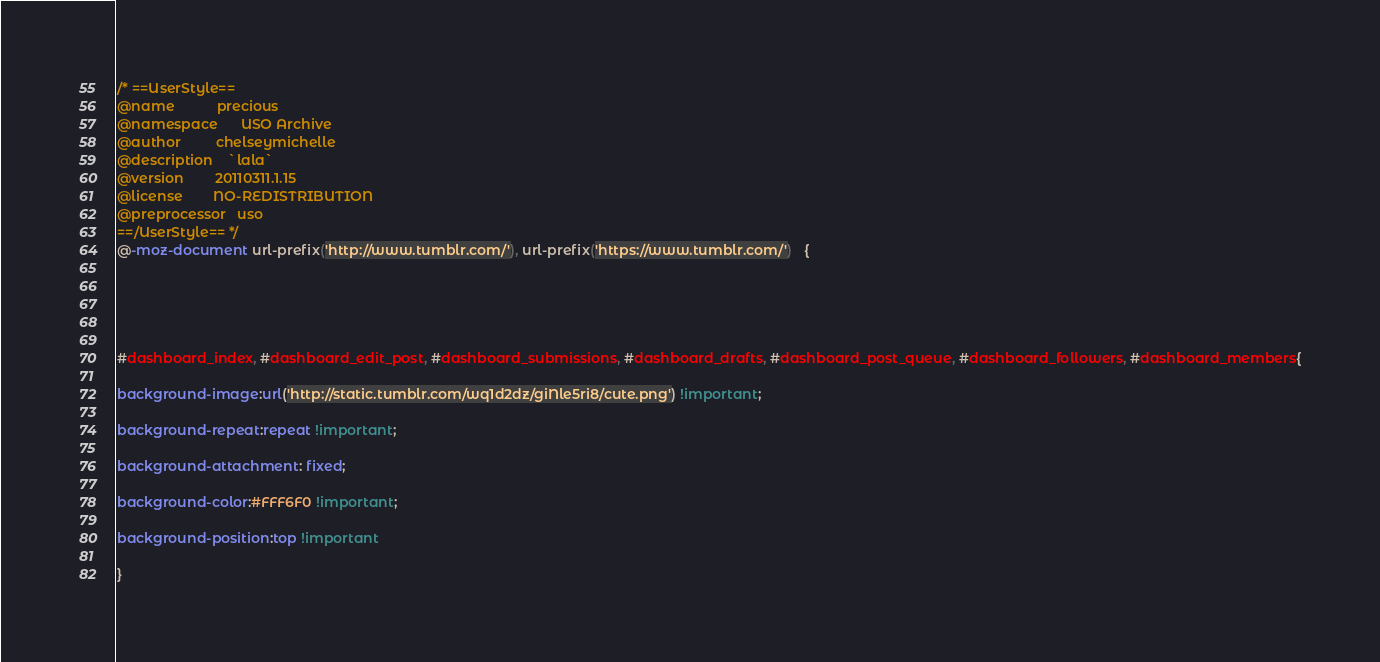<code> <loc_0><loc_0><loc_500><loc_500><_CSS_>/* ==UserStyle==
@name           precious
@namespace      USO Archive
@author         chelseymichelle
@description    `lala`
@version        20110311.1.15
@license        NO-REDISTRIBUTION
@preprocessor   uso
==/UserStyle== */
@-moz-document url-prefix('http://www.tumblr.com/'), url-prefix('https://www.tumblr.com/')   {





#dashboard_index, #dashboard_edit_post, #dashboard_submissions, #dashboard_drafts, #dashboard_post_queue, #dashboard_followers, #dashboard_members{

background-image:url('http://static.tumblr.com/wq1d2dz/giNle5ri8/cute.png') !important;

background-repeat:repeat !important;

background-attachment: fixed;

background-color:#FFF6F0 !important;

background-position:top !important

}






</code> 